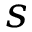<formula> <loc_0><loc_0><loc_500><loc_500>s</formula> 